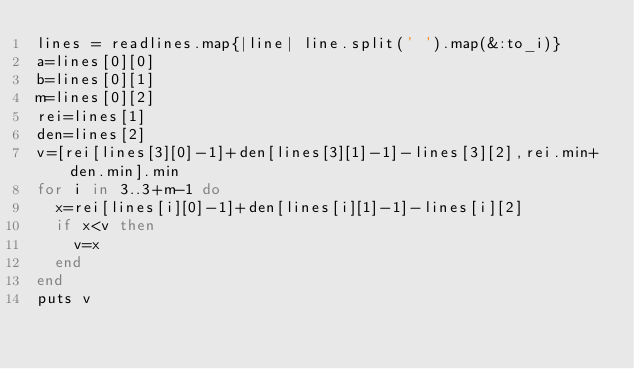Convert code to text. <code><loc_0><loc_0><loc_500><loc_500><_Ruby_>lines = readlines.map{|line| line.split(' ').map(&:to_i)}
a=lines[0][0]
b=lines[0][1]
m=lines[0][2]
rei=lines[1]
den=lines[2]
v=[rei[lines[3][0]-1]+den[lines[3][1]-1]-lines[3][2],rei.min+den.min].min
for i in 3..3+m-1 do
  x=rei[lines[i][0]-1]+den[lines[i][1]-1]-lines[i][2]
  if x<v then
    v=x
  end
end
puts v</code> 